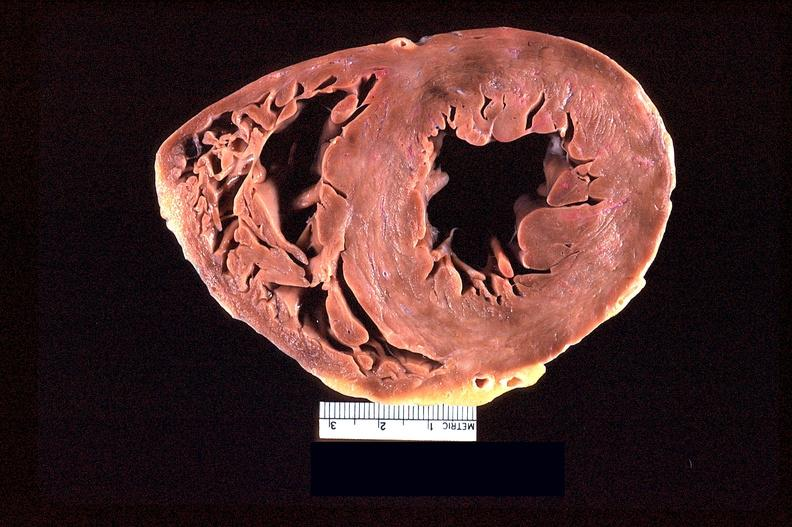what is present?
Answer the question using a single word or phrase. Cardiovascular 